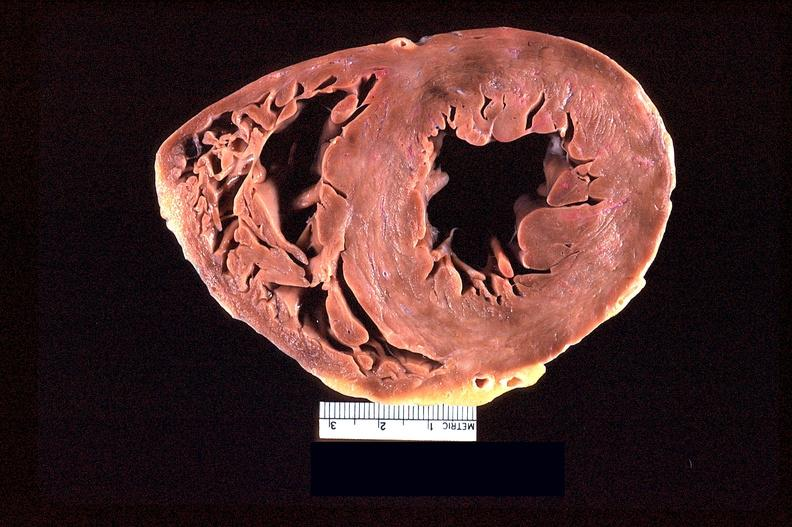what is present?
Answer the question using a single word or phrase. Cardiovascular 